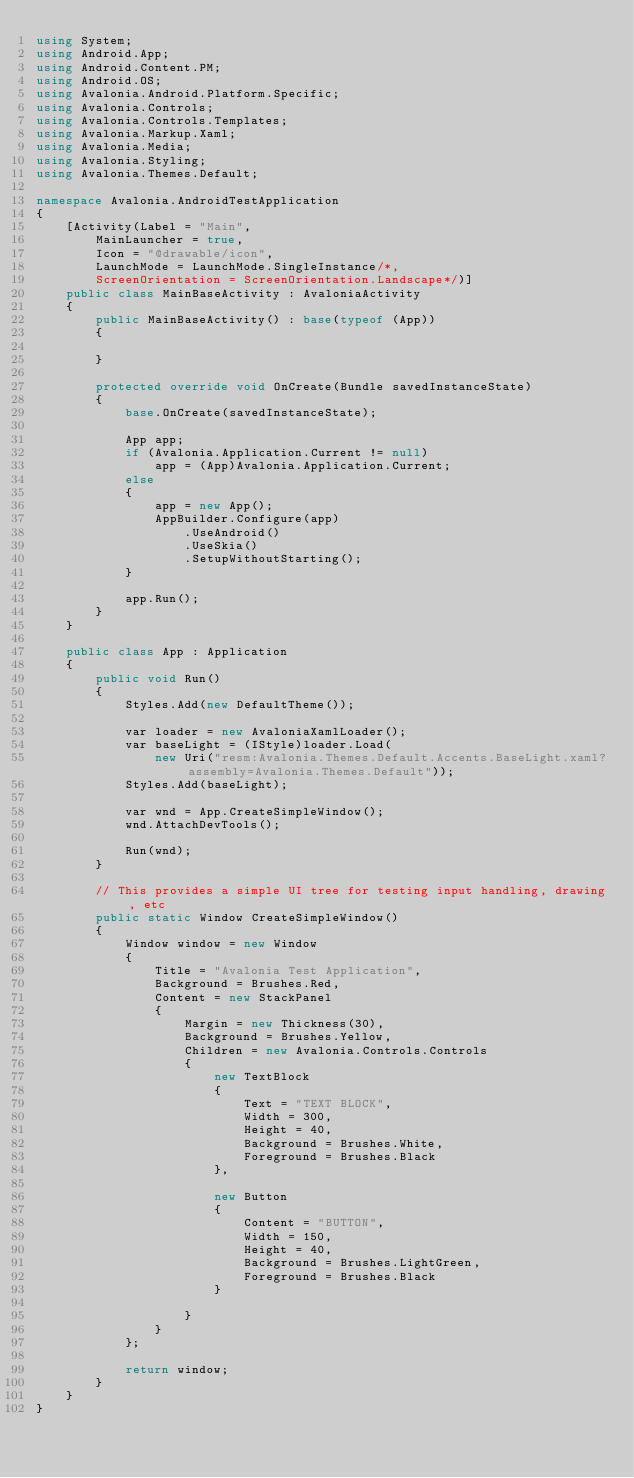<code> <loc_0><loc_0><loc_500><loc_500><_C#_>using System;
using Android.App;
using Android.Content.PM;
using Android.OS;
using Avalonia.Android.Platform.Specific;
using Avalonia.Controls;
using Avalonia.Controls.Templates;
using Avalonia.Markup.Xaml;
using Avalonia.Media;
using Avalonia.Styling;
using Avalonia.Themes.Default;

namespace Avalonia.AndroidTestApplication
{
    [Activity(Label = "Main",
        MainLauncher = true,
        Icon = "@drawable/icon",
        LaunchMode = LaunchMode.SingleInstance/*,
        ScreenOrientation = ScreenOrientation.Landscape*/)]
    public class MainBaseActivity : AvaloniaActivity
    {
        public MainBaseActivity() : base(typeof (App))
        {

        }

        protected override void OnCreate(Bundle savedInstanceState)
        {
            base.OnCreate(savedInstanceState);

            App app;
            if (Avalonia.Application.Current != null)
                app = (App)Avalonia.Application.Current;
            else
            {
                app = new App();
                AppBuilder.Configure(app)
                    .UseAndroid()
                    .UseSkia()
                    .SetupWithoutStarting();
            }

            app.Run();
        }
    }

    public class App : Application
    {
        public void Run()
        {
            Styles.Add(new DefaultTheme());

            var loader = new AvaloniaXamlLoader();
            var baseLight = (IStyle)loader.Load(
                new Uri("resm:Avalonia.Themes.Default.Accents.BaseLight.xaml?assembly=Avalonia.Themes.Default"));
            Styles.Add(baseLight);

            var wnd = App.CreateSimpleWindow();
            wnd.AttachDevTools();

            Run(wnd);
        }

        // This provides a simple UI tree for testing input handling, drawing, etc
        public static Window CreateSimpleWindow()
        {
            Window window = new Window
            {
                Title = "Avalonia Test Application",
                Background = Brushes.Red,
                Content = new StackPanel
                {
                    Margin = new Thickness(30),
                    Background = Brushes.Yellow,
                    Children = new Avalonia.Controls.Controls
                    {
                        new TextBlock
                        {
                            Text = "TEXT BLOCK",
                            Width = 300,
                            Height = 40,
                            Background = Brushes.White,
                            Foreground = Brushes.Black
                        },

                        new Button
                        {
                            Content = "BUTTON",
                            Width = 150,
                            Height = 40,
                            Background = Brushes.LightGreen,
                            Foreground = Brushes.Black
                        }

                    }
                }
            };

            return window;
        }
    }
}
</code> 